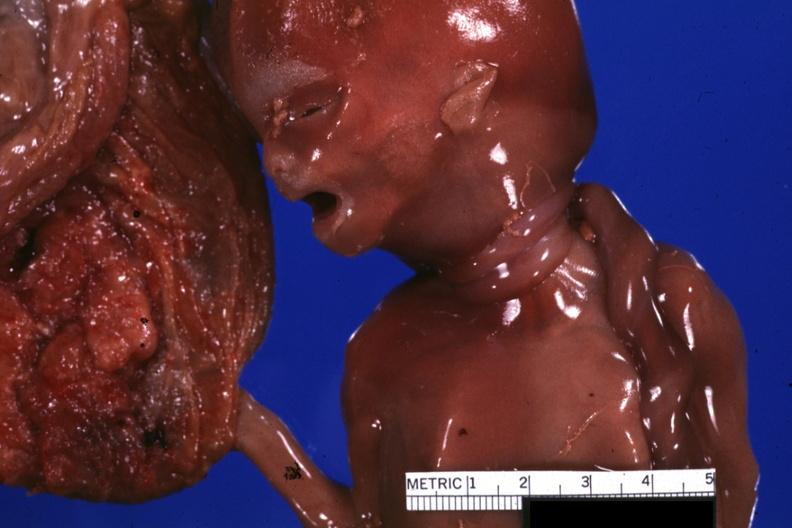s opened muscle present?
Answer the question using a single word or phrase. No 